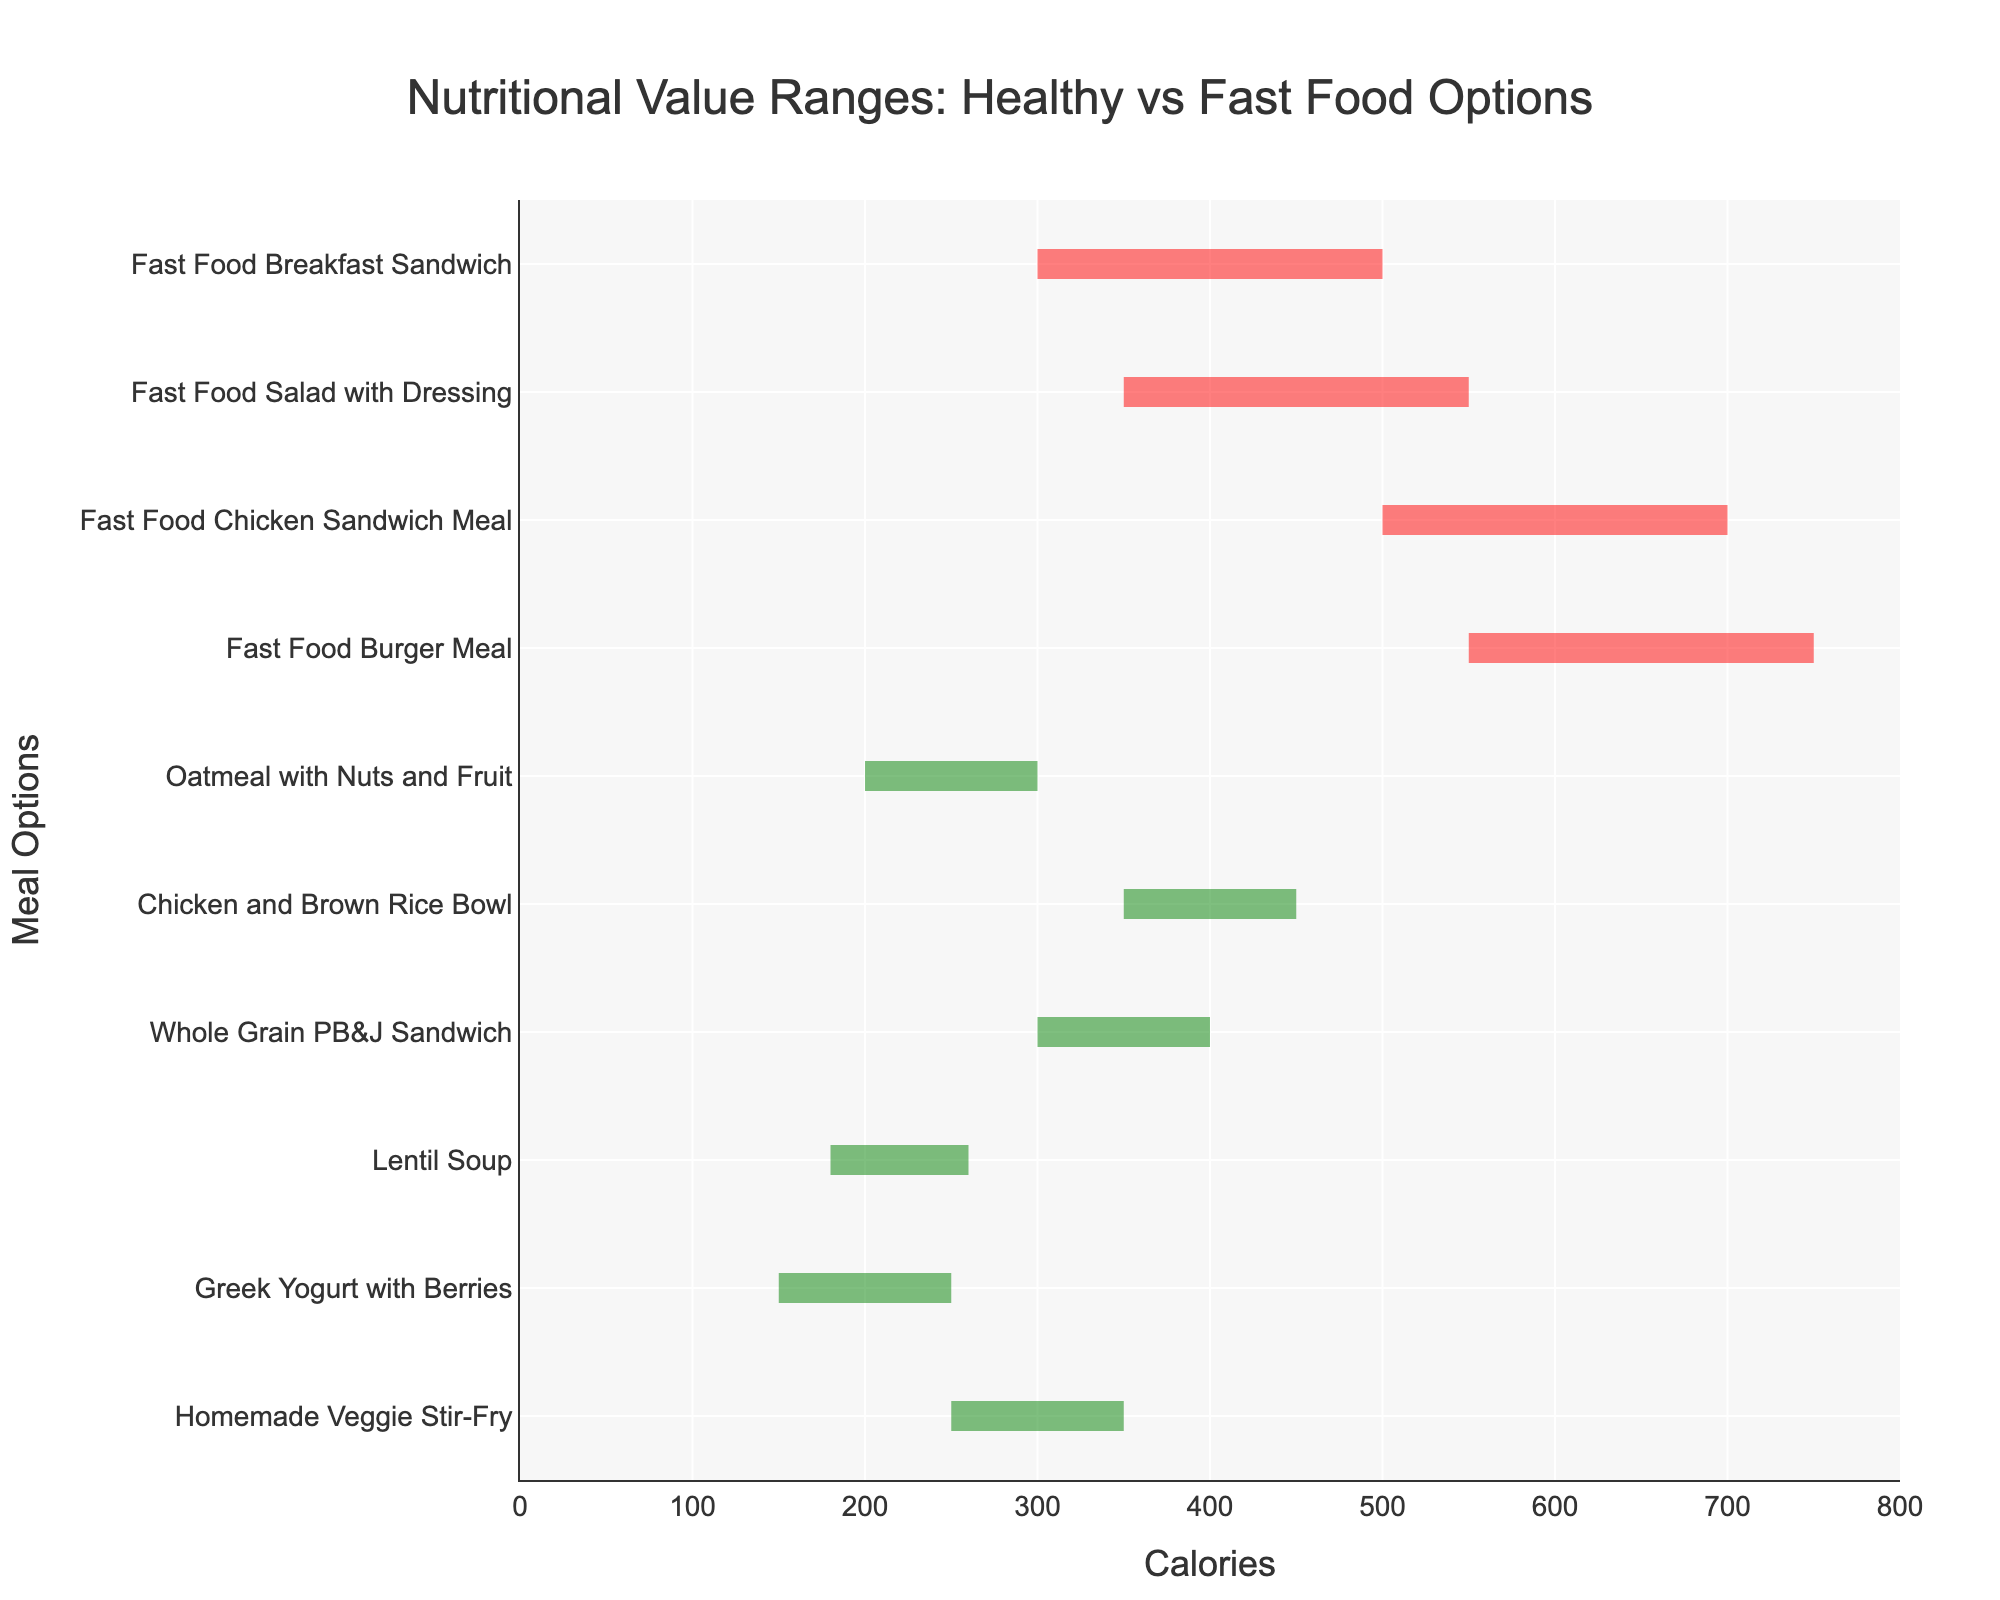Which meal option has the lowest median calorie value? The meal option with the lowest median calorie value is found by looking at the median values in the middle of each fan. The "Greek Yogurt with Berries" has the lowest median calorie value of 200 calories.
Answer: Greek Yogurt with Berries Which fast food option has the highest high value? To find the fast food option with the highest upper value, check the high (rightmost) values for each fast food category. The "Fast Food Burger Meal" has the highest high value at 750 calories.
Answer: Fast Food Burger Meal What is the range of calories for "Lentil Soup"? The range of calories for "Lentil Soup" can be found by subtracting the low value from the high value (260 - 180). This indicates that the calorie range is 80 calories.
Answer: 80 calories Which healthy meal option has the widest range in calorie values? To identify the healthy meal option with the widest range, compare the differences between the high and low values for each option. The "Chicken and Brown Rice Bowl" has a range of 100 calories (450 - 350).
Answer: Chicken and Brown Rice Bowl How does the median calorie value of the "Fast Food Breakfast Sandwich" compare to the "Oatmeal with Nuts and Fruit"? Compare the median value of the "Fast Food Breakfast Sandwich" (400 calories) with the median value of the "Oatmeal with Nuts and Fruit" (250 calories). The "Fast Food Breakfast Sandwich" has a median calorie value that is 150 calories higher.
Answer: 150 calories higher Which healthy meal option overlaps in calorie range with the "Fast Food Salad with Dressing"? To determine any overlaps, compare the calorie ranges. "Homemade Veggie Stir-Fry" ranges from 250 to 350 calories, which overlaps with the low end of the "Fast Food Salad with Dressing" (350 - 550 calories).
Answer: Homemade Veggie Stir-Fry What is the average of the high values for all mentioned fast food options? Add the high values of all fast food options (750 + 700 + 550 + 500) to get 2500. Since there are 4 fast food options, divide the sum by 4 to get the average: 2500 / 4 = 625.
Answer: 625 Which fast food option has a lower minimum calorie value than any healthy meal option's highest value? Scan the low values of fast food options and compare them to the high values of healthy meal options. The "Fast Food Breakfast Sandwich" has a low value of 300, which is lower compared to "Whole Grain PB&J Sandwich" and others whose high values are above 300.
Answer: Fast Food Breakfast Sandwich What is the difference in median calorie values between the "Whole Grain PB&J Sandwich" and "Fast Food Chicken Sandwich Meal"? Subtract the median value of "Fast Food Chicken Sandwich Meal" (600) from "Whole Grain PB&J Sandwich" (350). The difference is 600 - 350 = 250 calories.
Answer: 250 calories Which healthy meal has the smallest difference between its high and low values? The smallest difference is found by comparing the ranges (high - low) of each healthy meal. The "Greek Yogurt with Berries" has the smallest difference, with a range of 100 calories (250 - 150).
Answer: Greek Yogurt with Berries 